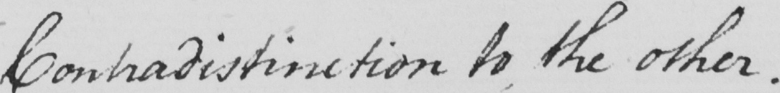Can you tell me what this handwritten text says? Contradistinction to the other . 